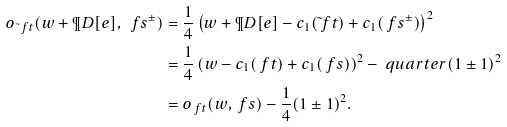Convert formula to latex. <formula><loc_0><loc_0><loc_500><loc_500>o _ { \tilde { \ } f t } ( w + \P D [ e ] , \ f s ^ { \pm } ) & = \frac { 1 } { 4 } \left ( w + \P D [ e ] - c _ { 1 } ( \tilde { \ } f t ) + c _ { 1 } ( \ f s ^ { \pm } ) \right ) ^ { 2 } \\ & = \frac { 1 } { 4 } \left ( w - c _ { 1 } ( \ f t ) + c _ { 1 } ( \ f s ) \right ) ^ { 2 } - \ q u a r t e r ( 1 \pm 1 ) ^ { 2 } \\ & = o _ { \ f t } ( w , \ f s ) - \frac { 1 } { 4 } ( 1 \pm 1 ) ^ { 2 } .</formula> 